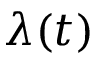<formula> <loc_0><loc_0><loc_500><loc_500>\lambda ( t )</formula> 